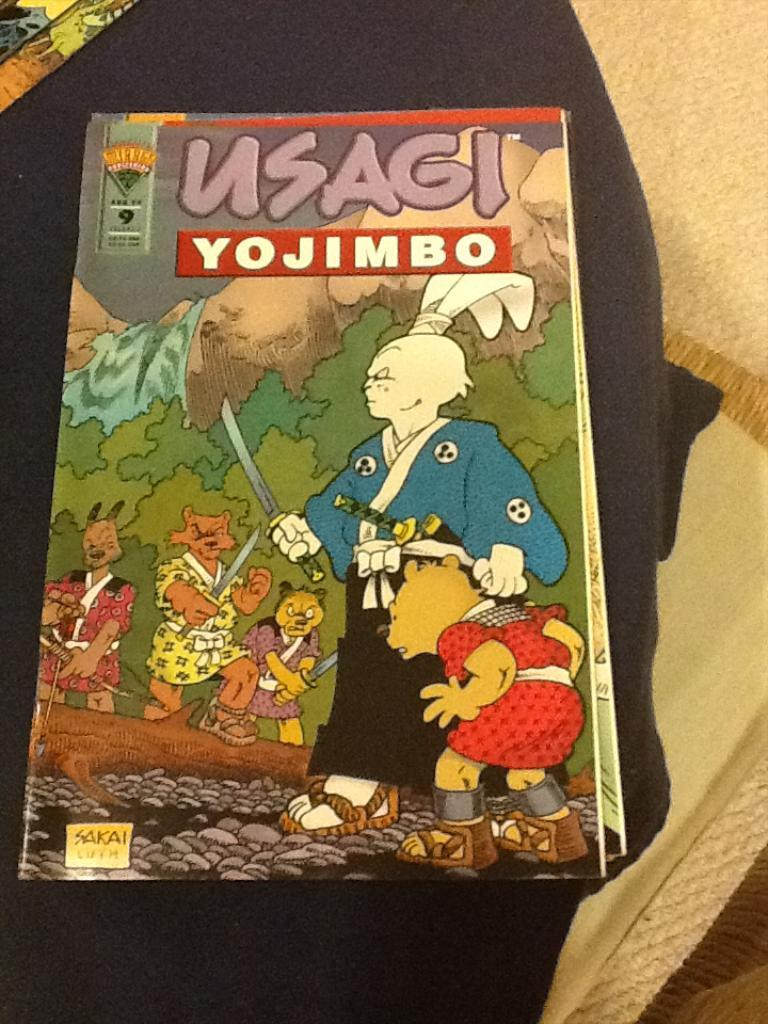What is present in the image? There is a book in the image. What type of pictures are on the book? The book has animation pictures on it. What type of ship can be seen in the image? There is no ship present in the image; it only features a book with animation pictures. What type of jeans is the person wearing in the image? There is no person or jeans present in the image; it only features a book with animation pictures. 